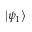Convert formula to latex. <formula><loc_0><loc_0><loc_500><loc_500>\left | { \psi _ { 1 } } \right \rangle</formula> 